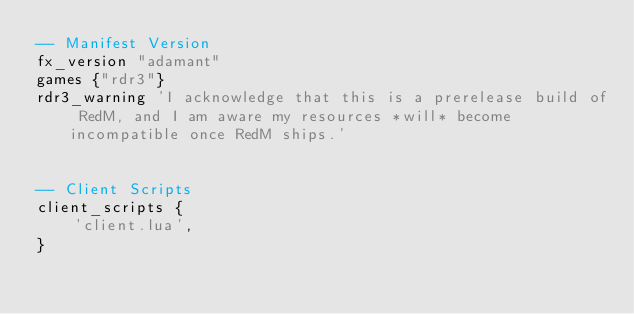Convert code to text. <code><loc_0><loc_0><loc_500><loc_500><_Lua_>-- Manifest Version
fx_version "adamant"
games {"rdr3"}
rdr3_warning 'I acknowledge that this is a prerelease build of RedM, and I am aware my resources *will* become incompatible once RedM ships.'


-- Client Scripts
client_scripts {
	'client.lua',
}
</code> 